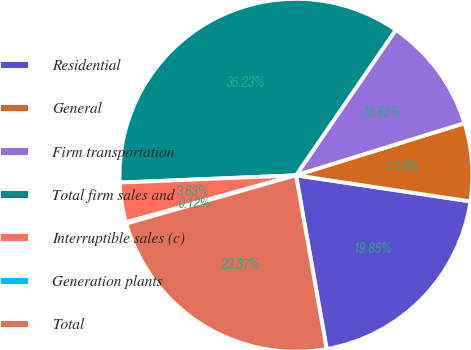<chart> <loc_0><loc_0><loc_500><loc_500><pie_chart><fcel>Residential<fcel>General<fcel>Firm transportation<fcel>Total firm sales and<fcel>Interruptible sales (c)<fcel>Generation plants<fcel>Total<nl><fcel>19.85%<fcel>7.14%<fcel>10.65%<fcel>35.23%<fcel>3.63%<fcel>0.12%<fcel>23.37%<nl></chart> 